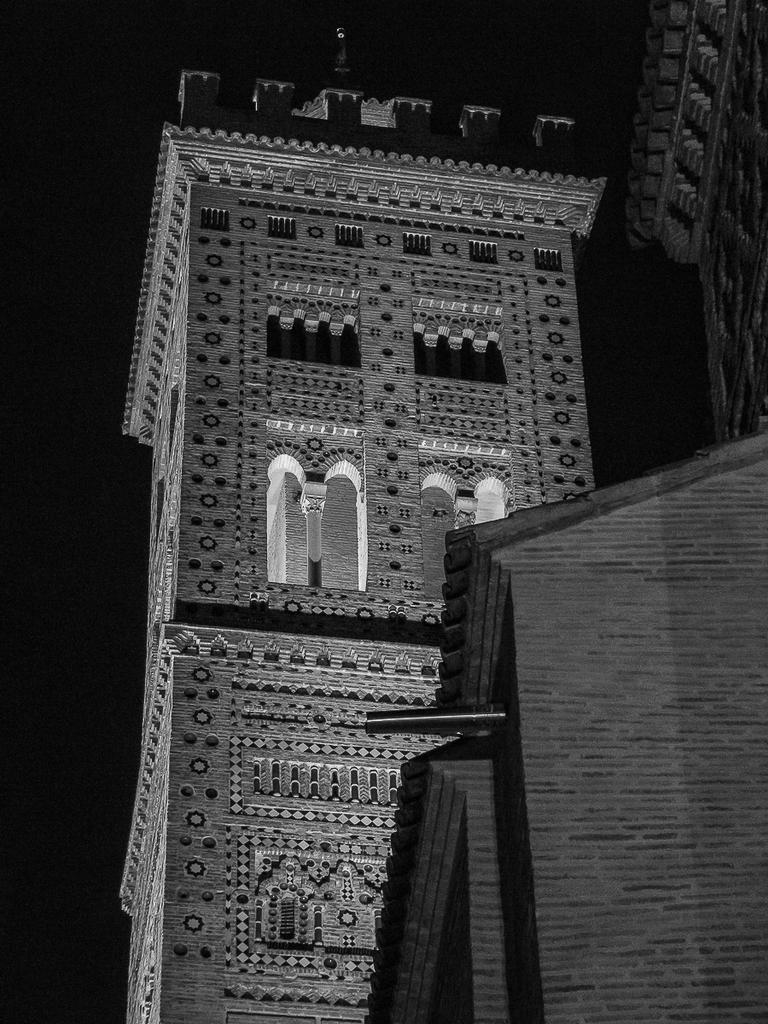What is the main subject of the image? The main subject of the image is a building. What can be observed about the background of the image? The background of the image is dark. How would you describe the color scheme of the image? The image is black and white. Can you tell me how many berries are present in the image? There are no berries present in the image; it features a building with a dark background and a black and white color scheme. 